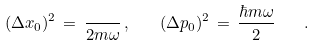Convert formula to latex. <formula><loc_0><loc_0><loc_500><loc_500>( \Delta x _ { 0 } ) ^ { 2 } \, = \, \frac { } { 2 m \omega } \, , \quad ( \Delta p _ { 0 } ) ^ { 2 } \, = \, \frac { \hbar { m } \omega } { 2 } \quad .</formula> 